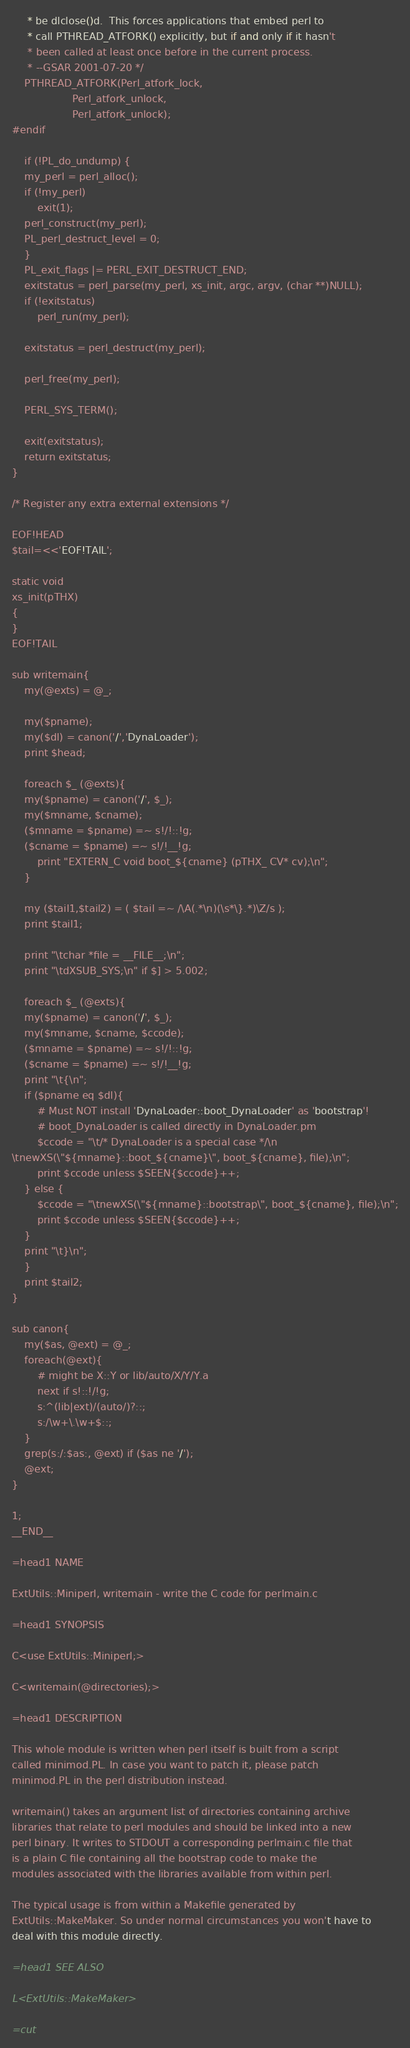<code> <loc_0><loc_0><loc_500><loc_500><_Perl_>     * be dlclose()d.  This forces applications that embed perl to
     * call PTHREAD_ATFORK() explicitly, but if and only if it hasn't
     * been called at least once before in the current process.
     * --GSAR 2001-07-20 */
    PTHREAD_ATFORK(Perl_atfork_lock,
                   Perl_atfork_unlock,
                   Perl_atfork_unlock);
#endif

    if (!PL_do_undump) {
	my_perl = perl_alloc();
	if (!my_perl)
	    exit(1);
	perl_construct(my_perl);
	PL_perl_destruct_level = 0;
    }
    PL_exit_flags |= PERL_EXIT_DESTRUCT_END;
    exitstatus = perl_parse(my_perl, xs_init, argc, argv, (char **)NULL);
    if (!exitstatus)
        perl_run(my_perl);
      
    exitstatus = perl_destruct(my_perl);

    perl_free(my_perl);

    PERL_SYS_TERM();

    exit(exitstatus);
    return exitstatus;
}

/* Register any extra external extensions */

EOF!HEAD
$tail=<<'EOF!TAIL';

static void
xs_init(pTHX)
{
}
EOF!TAIL

sub writemain{
    my(@exts) = @_;

    my($pname);
    my($dl) = canon('/','DynaLoader');
    print $head;

    foreach $_ (@exts){
	my($pname) = canon('/', $_);
	my($mname, $cname);
	($mname = $pname) =~ s!/!::!g;
	($cname = $pname) =~ s!/!__!g;
        print "EXTERN_C void boot_${cname} (pTHX_ CV* cv);\n";
    }

    my ($tail1,$tail2) = ( $tail =~ /\A(.*\n)(\s*\}.*)\Z/s );
    print $tail1;

    print "\tchar *file = __FILE__;\n";
    print "\tdXSUB_SYS;\n" if $] > 5.002;

    foreach $_ (@exts){
	my($pname) = canon('/', $_);
	my($mname, $cname, $ccode);
	($mname = $pname) =~ s!/!::!g;
	($cname = $pname) =~ s!/!__!g;
	print "\t{\n";
	if ($pname eq $dl){
	    # Must NOT install 'DynaLoader::boot_DynaLoader' as 'bootstrap'!
	    # boot_DynaLoader is called directly in DynaLoader.pm
	    $ccode = "\t/* DynaLoader is a special case */\n
\tnewXS(\"${mname}::boot_${cname}\", boot_${cname}, file);\n";
	    print $ccode unless $SEEN{$ccode}++;
	} else {
	    $ccode = "\tnewXS(\"${mname}::bootstrap\", boot_${cname}, file);\n";
	    print $ccode unless $SEEN{$ccode}++;
	}
	print "\t}\n";
    }
    print $tail2;
}

sub canon{
    my($as, @ext) = @_;
	foreach(@ext){
	    # might be X::Y or lib/auto/X/Y/Y.a
		next if s!::!/!g;
	    s:^(lib|ext)/(auto/)?::;
	    s:/\w+\.\w+$::;
	}
	grep(s:/:$as:, @ext) if ($as ne '/');
	@ext;
}

1;
__END__

=head1 NAME

ExtUtils::Miniperl, writemain - write the C code for perlmain.c

=head1 SYNOPSIS

C<use ExtUtils::Miniperl;>

C<writemain(@directories);>

=head1 DESCRIPTION

This whole module is written when perl itself is built from a script
called minimod.PL. In case you want to patch it, please patch
minimod.PL in the perl distribution instead.

writemain() takes an argument list of directories containing archive
libraries that relate to perl modules and should be linked into a new
perl binary. It writes to STDOUT a corresponding perlmain.c file that
is a plain C file containing all the bootstrap code to make the
modules associated with the libraries available from within perl.

The typical usage is from within a Makefile generated by
ExtUtils::MakeMaker. So under normal circumstances you won't have to
deal with this module directly.

=head1 SEE ALSO

L<ExtUtils::MakeMaker>

=cut

</code> 